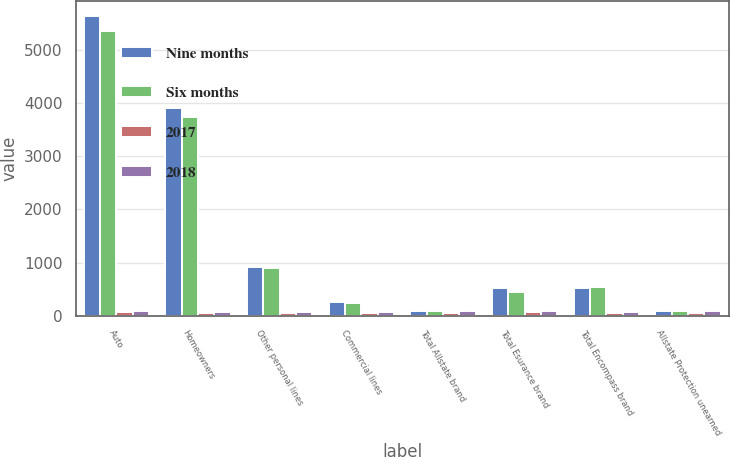<chart> <loc_0><loc_0><loc_500><loc_500><stacked_bar_chart><ecel><fcel>Auto<fcel>Homeowners<fcel>Other personal lines<fcel>Commercial lines<fcel>Total Allstate brand<fcel>Total Esurance brand<fcel>Total Encompass brand<fcel>Allstate Protection unearned<nl><fcel>Nine months<fcel>5635<fcel>3908<fcel>917<fcel>250<fcel>91.65<fcel>526<fcel>529<fcel>91.65<nl><fcel>Six months<fcel>5344<fcel>3745<fcel>895<fcel>246<fcel>91.65<fcel>448<fcel>535<fcel>91.65<nl><fcel>2017<fcel>71.1<fcel>43.3<fcel>43.4<fcel>44<fcel>58.1<fcel>71.1<fcel>43.8<fcel>58.1<nl><fcel>2018<fcel>96.6<fcel>75.4<fcel>75.3<fcel>75.2<fcel>86.7<fcel>96.6<fcel>75.7<fcel>86.6<nl></chart> 